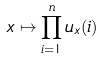Convert formula to latex. <formula><loc_0><loc_0><loc_500><loc_500>x \mapsto \prod _ { i = 1 } ^ { n } u _ { x } ( i )</formula> 